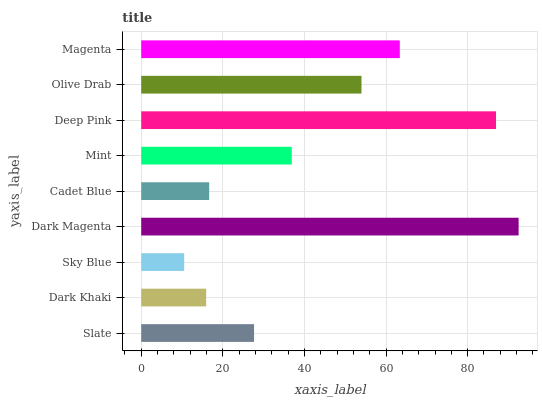Is Sky Blue the minimum?
Answer yes or no. Yes. Is Dark Magenta the maximum?
Answer yes or no. Yes. Is Dark Khaki the minimum?
Answer yes or no. No. Is Dark Khaki the maximum?
Answer yes or no. No. Is Slate greater than Dark Khaki?
Answer yes or no. Yes. Is Dark Khaki less than Slate?
Answer yes or no. Yes. Is Dark Khaki greater than Slate?
Answer yes or no. No. Is Slate less than Dark Khaki?
Answer yes or no. No. Is Mint the high median?
Answer yes or no. Yes. Is Mint the low median?
Answer yes or no. Yes. Is Olive Drab the high median?
Answer yes or no. No. Is Dark Khaki the low median?
Answer yes or no. No. 